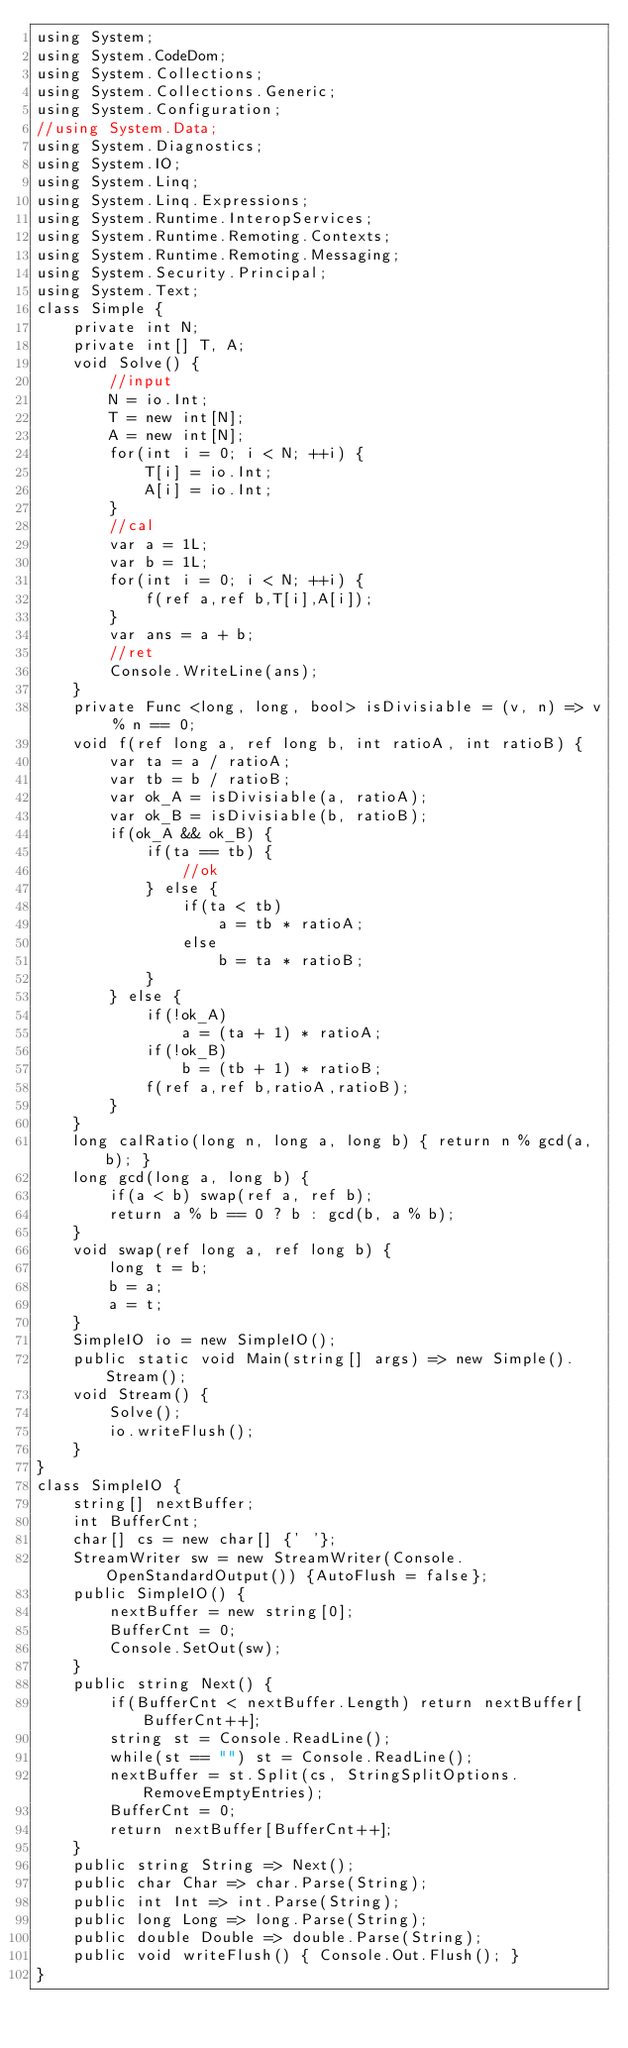Convert code to text. <code><loc_0><loc_0><loc_500><loc_500><_C#_>using System;
using System.CodeDom;
using System.Collections;
using System.Collections.Generic;
using System.Configuration;
//using System.Data;
using System.Diagnostics;
using System.IO;
using System.Linq;
using System.Linq.Expressions;
using System.Runtime.InteropServices;
using System.Runtime.Remoting.Contexts;
using System.Runtime.Remoting.Messaging;
using System.Security.Principal;
using System.Text;
class Simple {
    private int N;
    private int[] T, A;
    void Solve() {        
        //input
        N = io.Int;
        T = new int[N];
        A = new int[N];        
        for(int i = 0; i < N; ++i) {
            T[i] = io.Int;
            A[i] = io.Int;            
        }
        //cal
        var a = 1L;
        var b = 1L;
        for(int i = 0; i < N; ++i) {            
            f(ref a,ref b,T[i],A[i]);       
        }
        var ans = a + b;
        //ret
        Console.WriteLine(ans);
    }
    private Func <long, long, bool> isDivisiable = (v, n) => v % n == 0;
    void f(ref long a, ref long b, int ratioA, int ratioB) {
        var ta = a / ratioA;
        var tb = b / ratioB;
        var ok_A = isDivisiable(a, ratioA);
        var ok_B = isDivisiable(b, ratioB);
        if(ok_A && ok_B) {
            if(ta == tb) {
                //ok
            } else {
                if(ta < tb)  
                    a = tb * ratioA; 
                else  
                    b = ta * ratioB; 
            }
        } else {
            if(!ok_A) 
                a = (ta + 1) * ratioA; 
            if(!ok_B) 
                b = (tb + 1) * ratioB; 
            f(ref a,ref b,ratioA,ratioB);
        }
    }
    long calRatio(long n, long a, long b) { return n % gcd(a, b); }
    long gcd(long a, long b) {
        if(a < b) swap(ref a, ref b);
        return a % b == 0 ? b : gcd(b, a % b);
    }
    void swap(ref long a, ref long b) {
        long t = b;
        b = a;
        a = t;
    }
    SimpleIO io = new SimpleIO();
    public static void Main(string[] args) => new Simple().Stream();
    void Stream() {
        Solve();
        io.writeFlush();
    }
}
class SimpleIO {
    string[] nextBuffer;
    int BufferCnt;
    char[] cs = new char[] {' '};
    StreamWriter sw = new StreamWriter(Console.OpenStandardOutput()) {AutoFlush = false};
    public SimpleIO() {
        nextBuffer = new string[0];
        BufferCnt = 0;
        Console.SetOut(sw);
    }
    public string Next() {
        if(BufferCnt < nextBuffer.Length) return nextBuffer[BufferCnt++];
        string st = Console.ReadLine();
        while(st == "") st = Console.ReadLine();
        nextBuffer = st.Split(cs, StringSplitOptions.RemoveEmptyEntries);
        BufferCnt = 0;
        return nextBuffer[BufferCnt++];
    }
    public string String => Next();
    public char Char => char.Parse(String);
    public int Int => int.Parse(String);
    public long Long => long.Parse(String);
    public double Double => double.Parse(String);
    public void writeFlush() { Console.Out.Flush(); }
}
</code> 